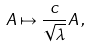<formula> <loc_0><loc_0><loc_500><loc_500>A \mapsto \frac { c } { \sqrt { \lambda } } A \, ,</formula> 